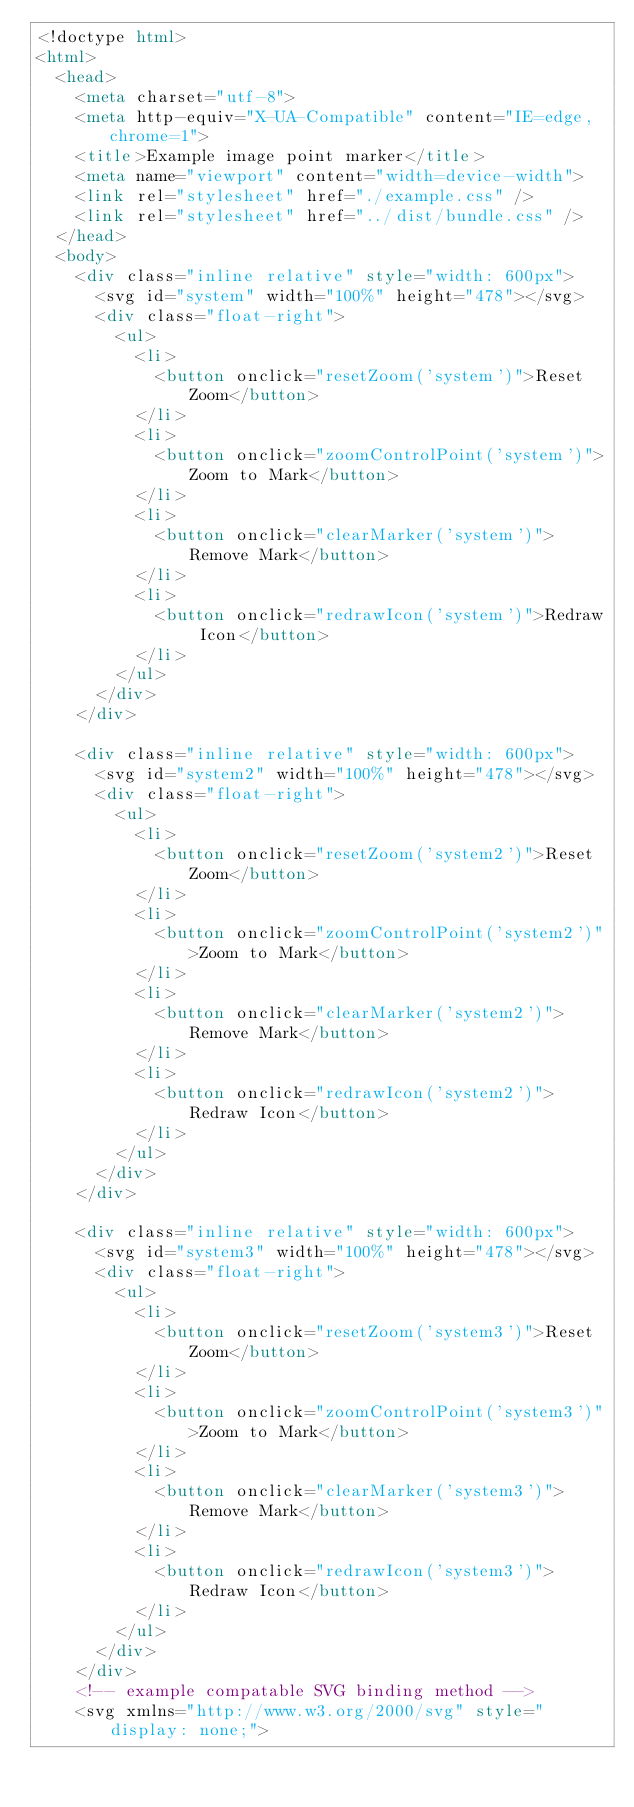Convert code to text. <code><loc_0><loc_0><loc_500><loc_500><_HTML_><!doctype html>
<html>
  <head>
    <meta charset="utf-8">
    <meta http-equiv="X-UA-Compatible" content="IE=edge,chrome=1">
    <title>Example image point marker</title>
    <meta name="viewport" content="width=device-width">
    <link rel="stylesheet" href="./example.css" />
    <link rel="stylesheet" href="../dist/bundle.css" />
  </head>
  <body>
    <div class="inline relative" style="width: 600px">
      <svg id="system" width="100%" height="478"></svg>
      <div class="float-right">
        <ul>
          <li>
            <button onclick="resetZoom('system')">Reset Zoom</button>
          </li>
          <li>
            <button onclick="zoomControlPoint('system')">Zoom to Mark</button>
          </li>
          <li>
            <button onclick="clearMarker('system')">Remove Mark</button>
          </li>
          <li>
            <button onclick="redrawIcon('system')">Redraw Icon</button>
          </li>
        </ul>
      </div>
    </div>

    <div class="inline relative" style="width: 600px">
      <svg id="system2" width="100%" height="478"></svg>
      <div class="float-right">
        <ul>
          <li>
            <button onclick="resetZoom('system2')">Reset Zoom</button>
          </li>
          <li>
            <button onclick="zoomControlPoint('system2')">Zoom to Mark</button>
          </li>
          <li>
            <button onclick="clearMarker('system2')">Remove Mark</button>
          </li>
          <li>
            <button onclick="redrawIcon('system2')">Redraw Icon</button>
          </li>
        </ul>
      </div>
    </div>

    <div class="inline relative" style="width: 600px">
      <svg id="system3" width="100%" height="478"></svg>
      <div class="float-right">
        <ul>
          <li>
            <button onclick="resetZoom('system3')">Reset Zoom</button>
          </li>
          <li>
            <button onclick="zoomControlPoint('system3')">Zoom to Mark</button>
          </li>
          <li>
            <button onclick="clearMarker('system3')">Remove Mark</button>
          </li>
          <li>
            <button onclick="redrawIcon('system3')">Redraw Icon</button>
          </li>
        </ul>
      </div>
    </div>
    <!-- example compatable SVG binding method -->
    <svg xmlns="http://www.w3.org/2000/svg" style="display: none;"></code> 